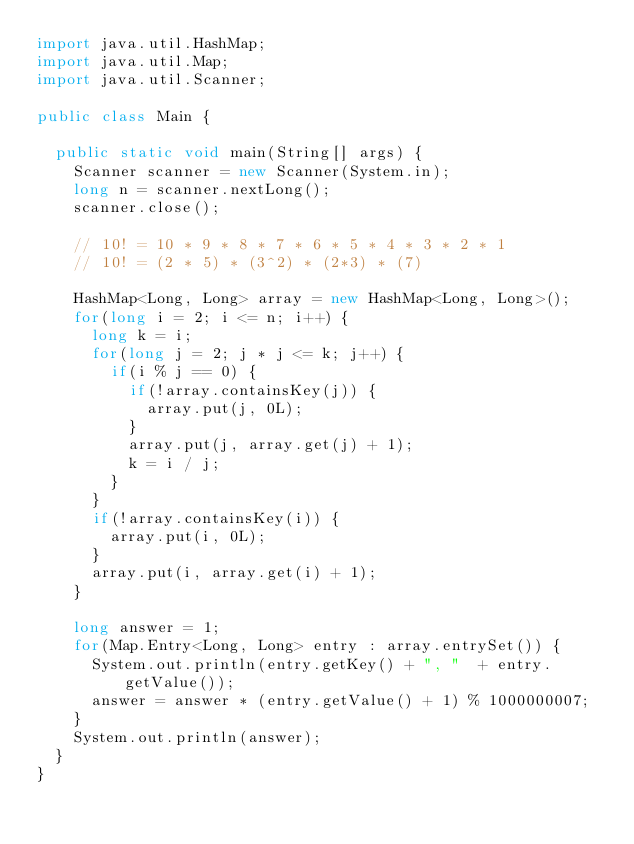Convert code to text. <code><loc_0><loc_0><loc_500><loc_500><_Java_>import java.util.HashMap;
import java.util.Map;
import java.util.Scanner;

public class Main {

	public static void main(String[] args) {
		Scanner scanner = new Scanner(System.in);
		long n = scanner.nextLong();
		scanner.close();

		// 10! = 10 * 9 * 8 * 7 * 6 * 5 * 4 * 3 * 2 * 1
		// 10! = (2 * 5) * (3^2) * (2*3) * (7)

		HashMap<Long, Long> array = new HashMap<Long, Long>();
		for(long i = 2; i <= n; i++) {
			long k = i;
			for(long j = 2; j * j <= k; j++) {
				if(i % j == 0) {
					if(!array.containsKey(j)) {
						array.put(j, 0L);
					}
					array.put(j, array.get(j) + 1);
					k = i / j;
				}
			}
			if(!array.containsKey(i)) {
				array.put(i, 0L);
			}
			array.put(i, array.get(i) + 1);
		}

		long answer = 1;
		for(Map.Entry<Long, Long> entry : array.entrySet()) {
			System.out.println(entry.getKey() + ", "  + entry.getValue());
			answer = answer * (entry.getValue() + 1) % 1000000007;
		}
		System.out.println(answer);
	}
}</code> 